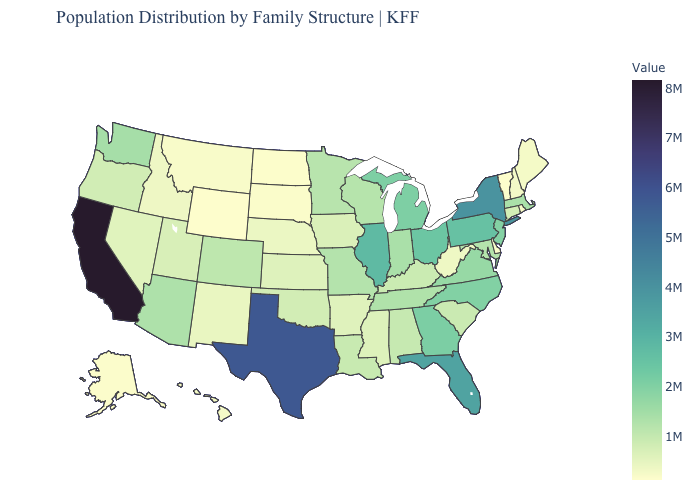Which states have the lowest value in the MidWest?
Short answer required. North Dakota. Does West Virginia have the lowest value in the USA?
Answer briefly. No. Does Wyoming have the lowest value in the USA?
Write a very short answer. Yes. 